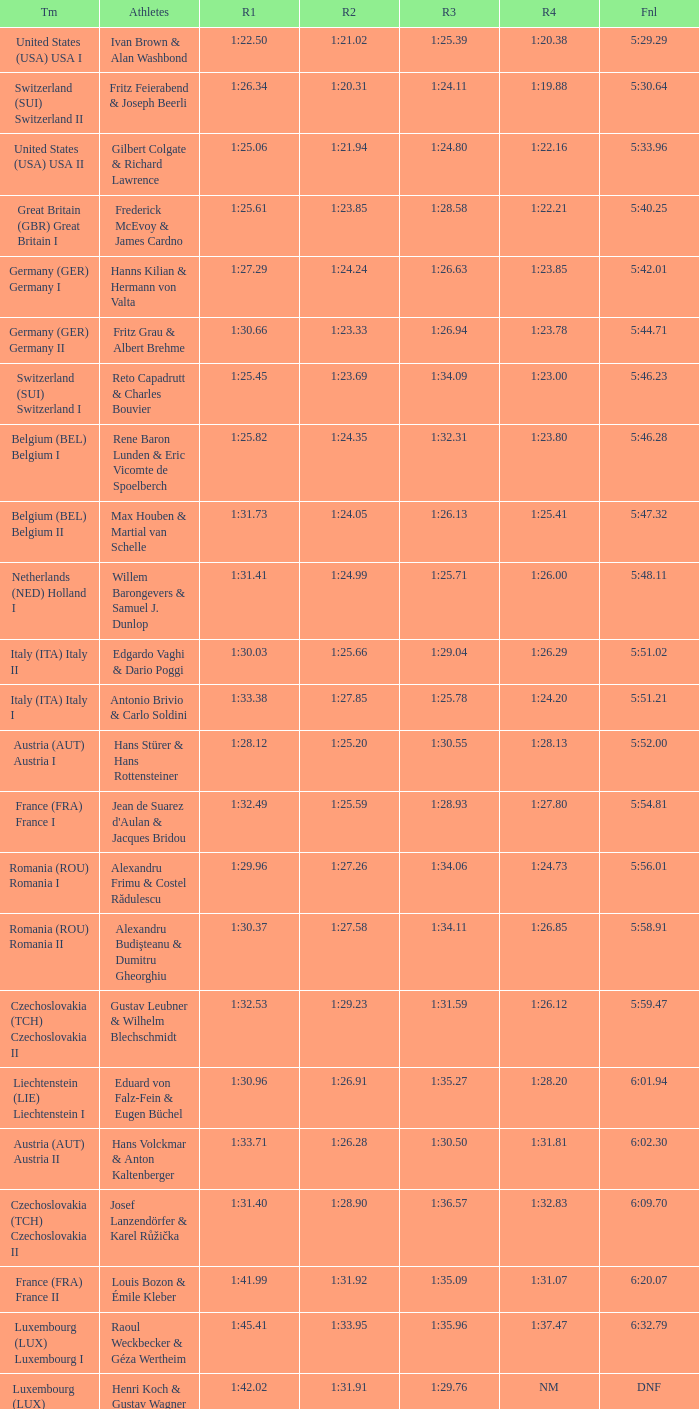Which Final has a Team of liechtenstein (lie) liechtenstein i? 6:01.94. 